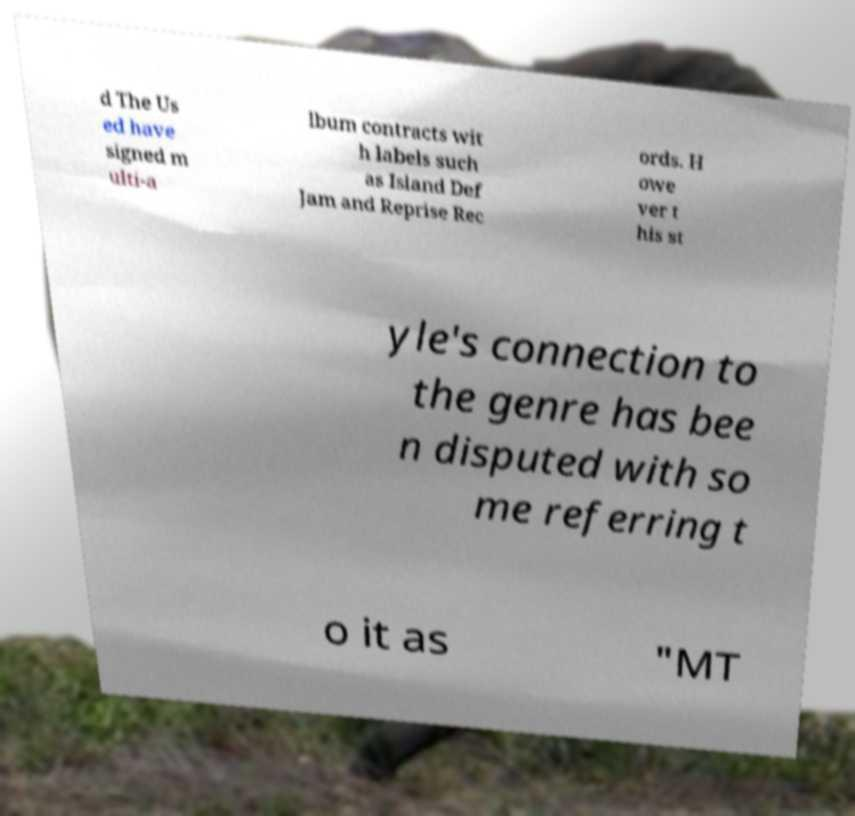There's text embedded in this image that I need extracted. Can you transcribe it verbatim? d The Us ed have signed m ulti-a lbum contracts wit h labels such as Island Def Jam and Reprise Rec ords. H owe ver t his st yle's connection to the genre has bee n disputed with so me referring t o it as "MT 